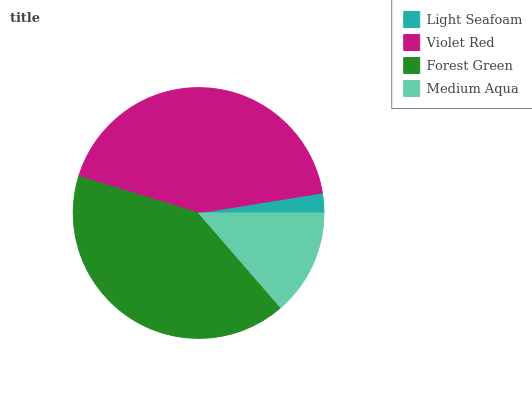Is Light Seafoam the minimum?
Answer yes or no. Yes. Is Violet Red the maximum?
Answer yes or no. Yes. Is Forest Green the minimum?
Answer yes or no. No. Is Forest Green the maximum?
Answer yes or no. No. Is Violet Red greater than Forest Green?
Answer yes or no. Yes. Is Forest Green less than Violet Red?
Answer yes or no. Yes. Is Forest Green greater than Violet Red?
Answer yes or no. No. Is Violet Red less than Forest Green?
Answer yes or no. No. Is Forest Green the high median?
Answer yes or no. Yes. Is Medium Aqua the low median?
Answer yes or no. Yes. Is Violet Red the high median?
Answer yes or no. No. Is Violet Red the low median?
Answer yes or no. No. 